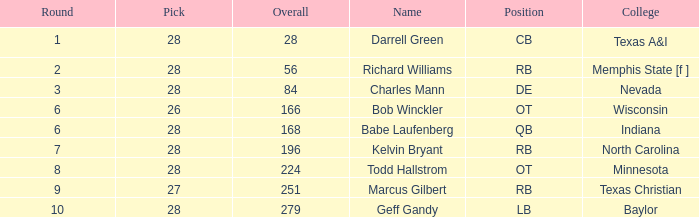What is the average round of the player from the college of baylor with a pick less than 28? None. 